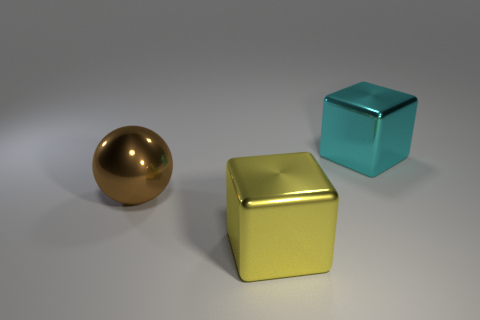What shape is the big brown thing that is made of the same material as the yellow block?
Your answer should be very brief. Sphere. What number of other things are the same shape as the big yellow metallic object?
Your answer should be very brief. 1. What number of large cubes are right of the yellow metal object?
Offer a terse response. 1. There is a cube that is behind the brown shiny thing; is it the same size as the shiny thing that is in front of the large brown ball?
Your answer should be very brief. Yes. What number of other objects are there of the same size as the yellow metallic object?
Your response must be concise. 2. There is a cyan object; is its size the same as the object in front of the brown sphere?
Give a very brief answer. Yes. There is a metal object that is in front of the cyan object and right of the sphere; what is its size?
Keep it short and to the point. Large. Is there another ball of the same color as the large sphere?
Your answer should be very brief. No. There is a big metal object that is right of the block in front of the big cyan shiny thing; what is its color?
Offer a very short reply. Cyan. Are there fewer brown balls behind the big sphere than large brown metal spheres in front of the yellow metallic block?
Ensure brevity in your answer.  No. 